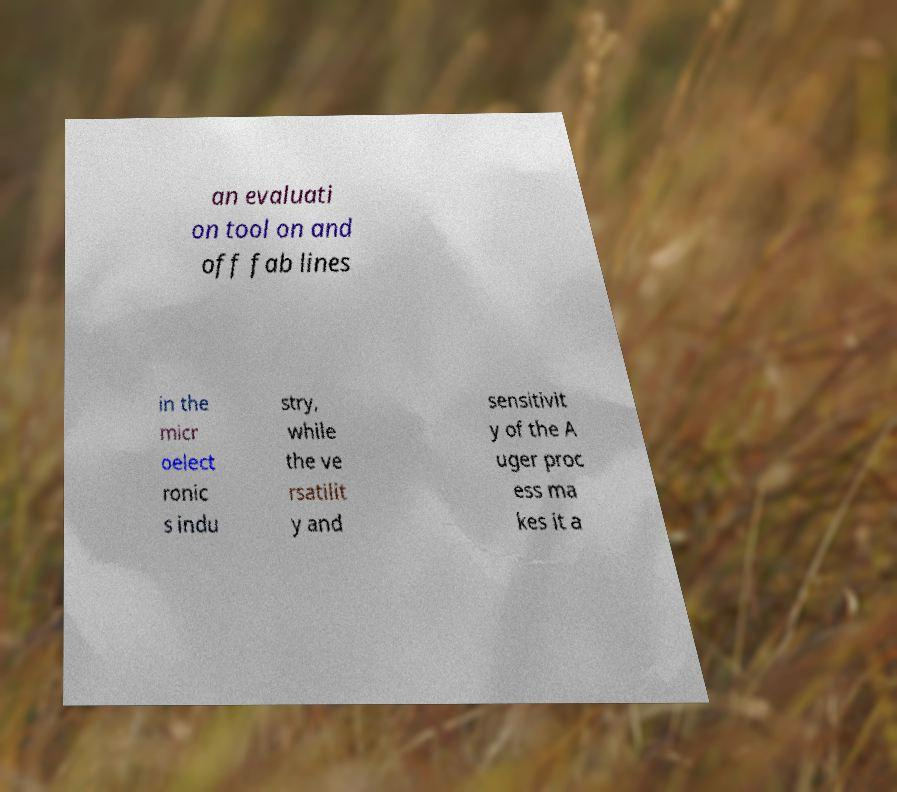Please read and relay the text visible in this image. What does it say? an evaluati on tool on and off fab lines in the micr oelect ronic s indu stry, while the ve rsatilit y and sensitivit y of the A uger proc ess ma kes it a 